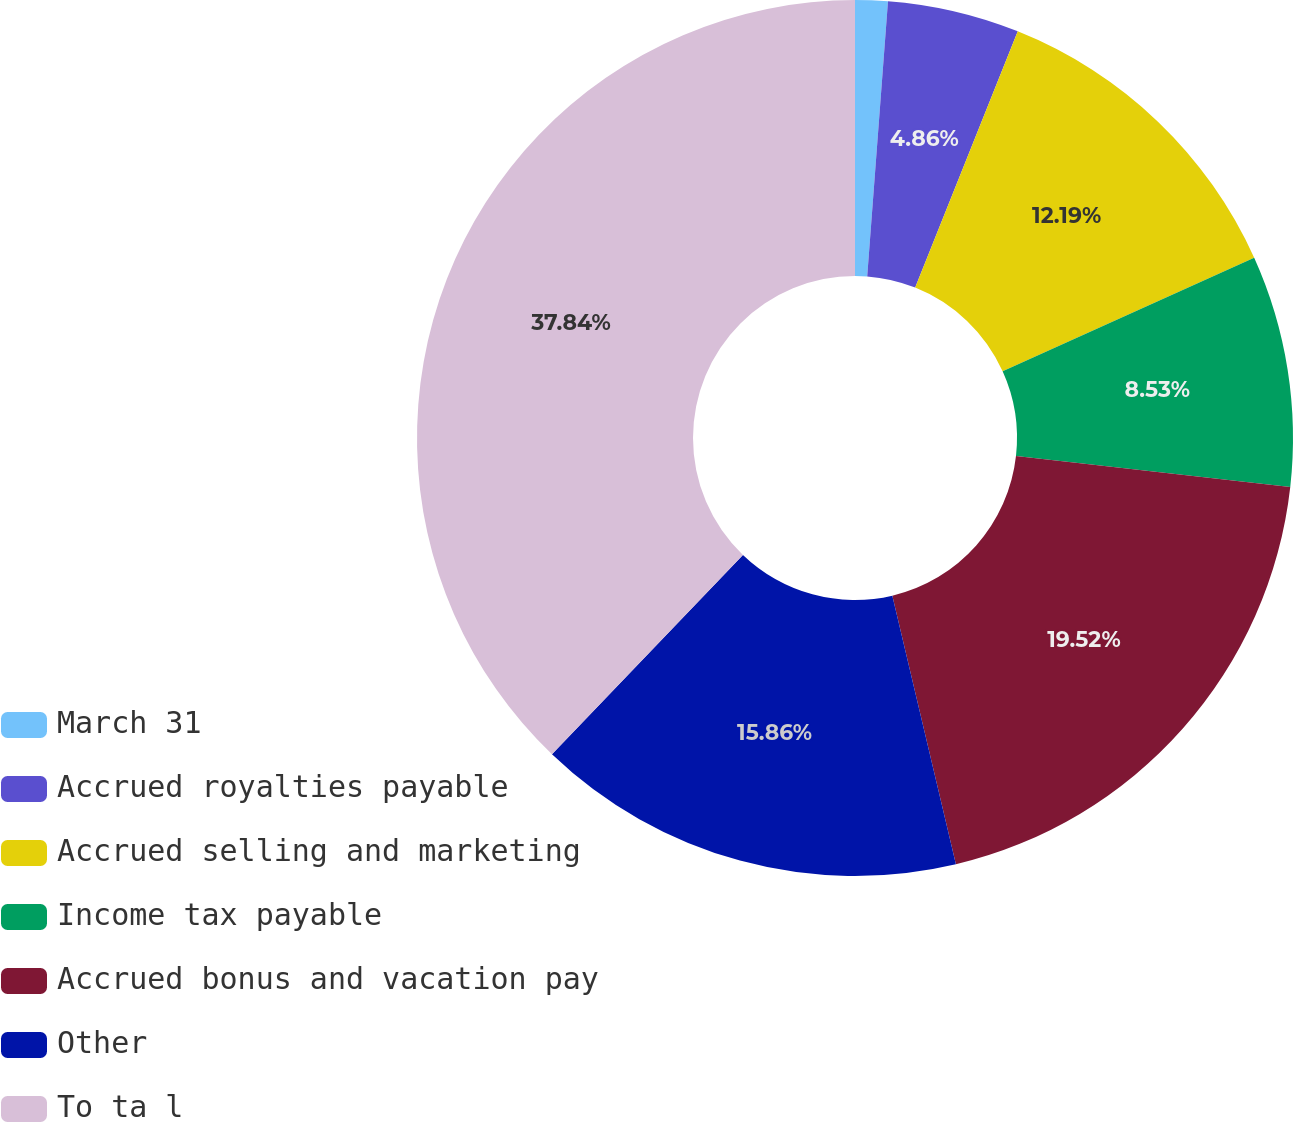Convert chart. <chart><loc_0><loc_0><loc_500><loc_500><pie_chart><fcel>March 31<fcel>Accrued royalties payable<fcel>Accrued selling and marketing<fcel>Income tax payable<fcel>Accrued bonus and vacation pay<fcel>Other<fcel>To ta l<nl><fcel>1.2%<fcel>4.86%<fcel>12.19%<fcel>8.53%<fcel>19.52%<fcel>15.86%<fcel>37.84%<nl></chart> 